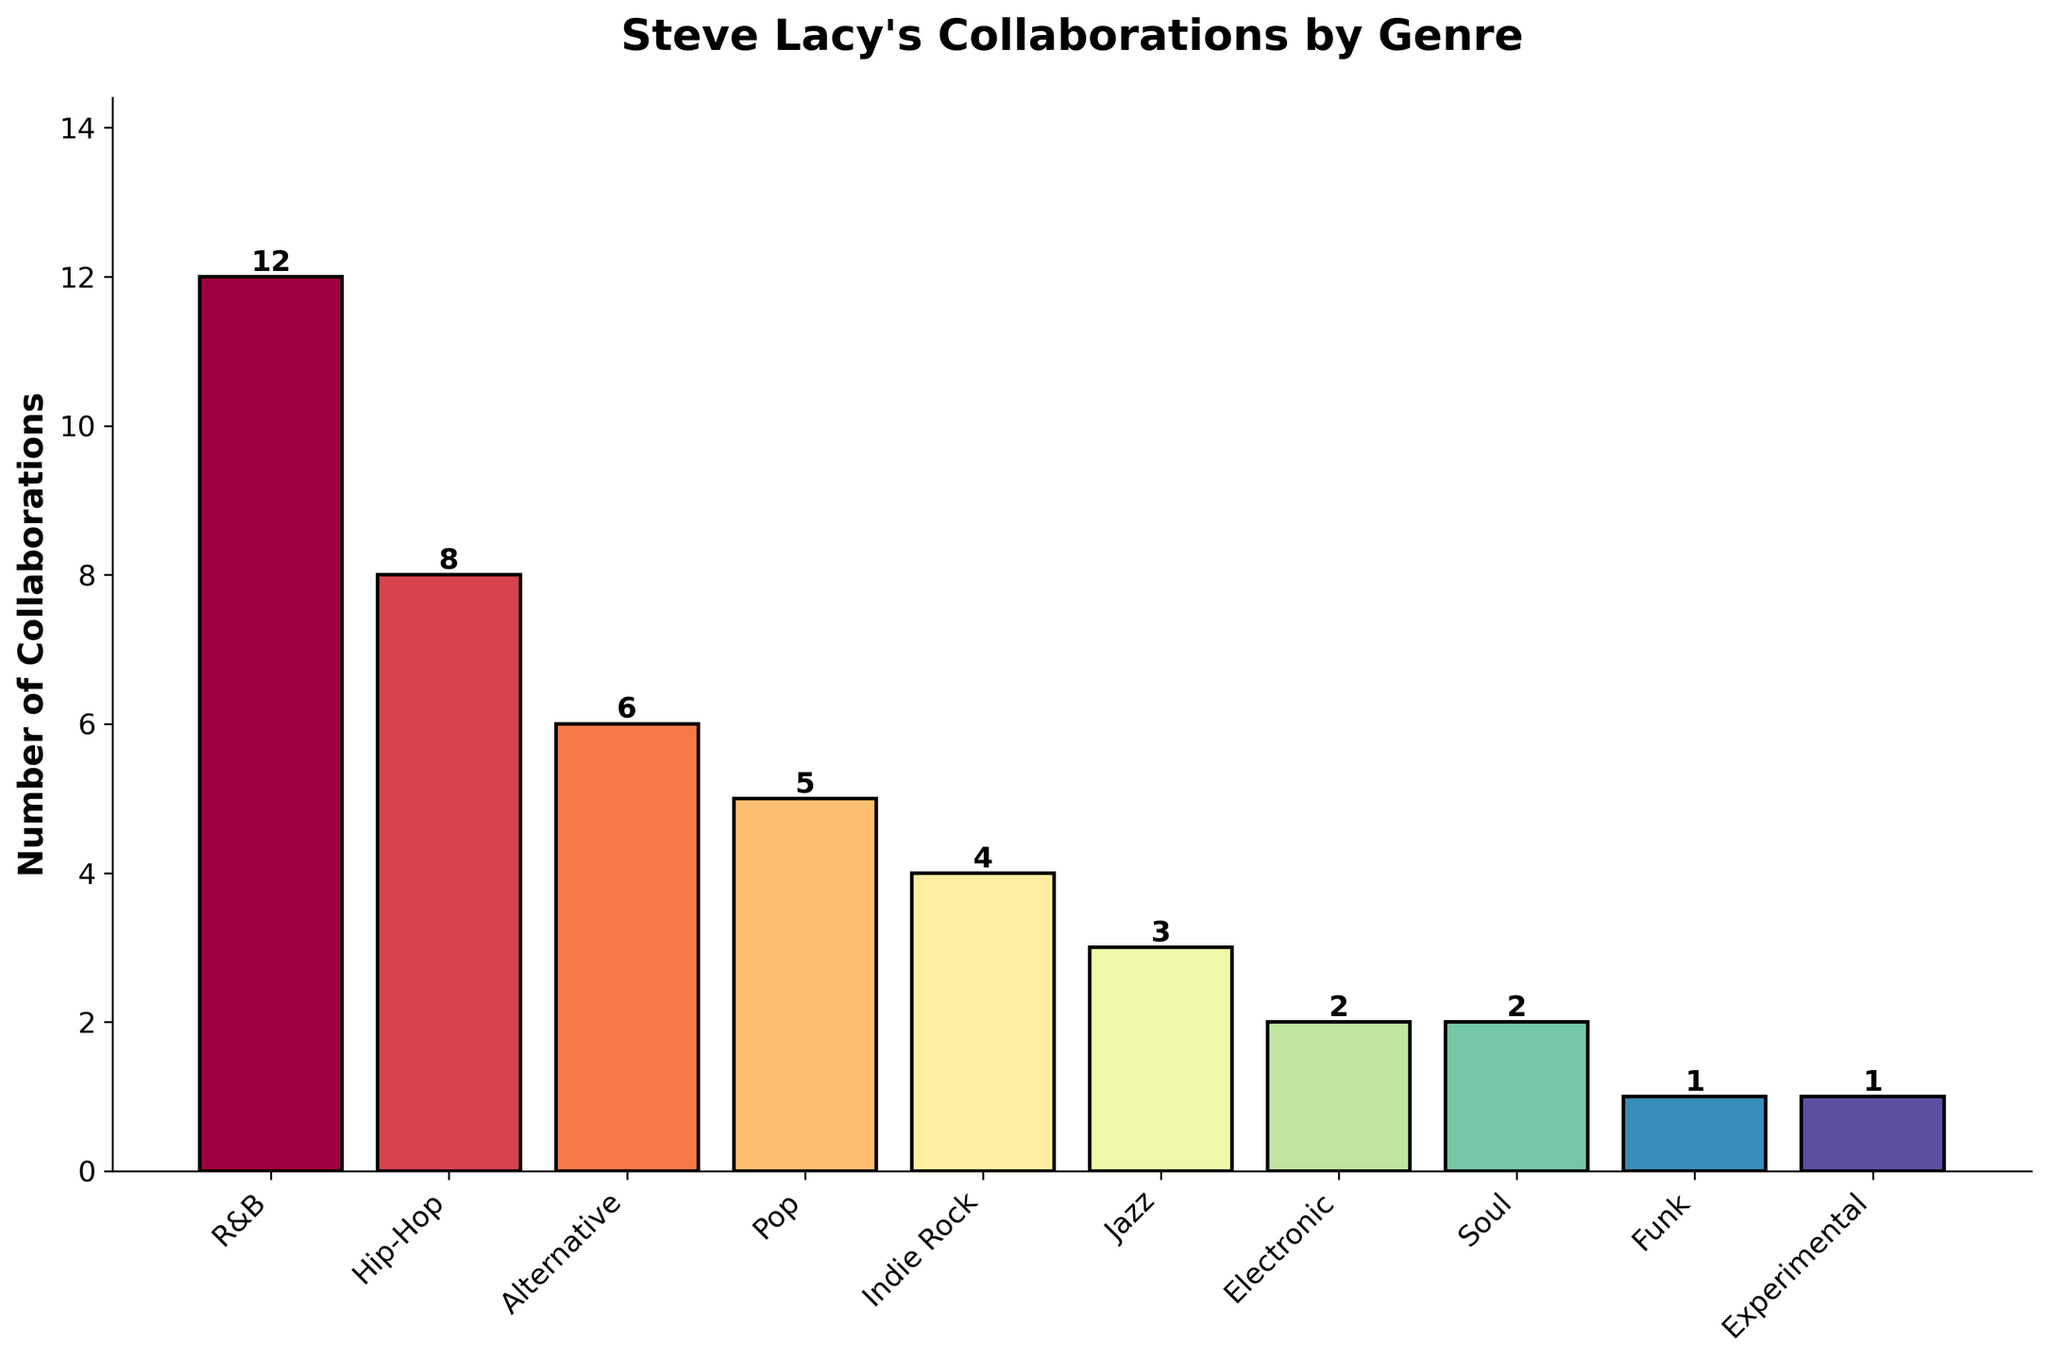what's the total number of collaborations across all genres? To find the total number of collaborations, add the number of collaborations for each genre. That's 12 (R&B) + 8 (Hip-Hop) + 6 (Alternative) + 5 (Pop) + 4 (Indie Rock) + 3 (Jazz) + 2 (Electronic) + 2 (Soul) + 1 (Funk) + 1 (Experimental). The sum is 44.
Answer: 44 which genre has the most collaborations with Steve Lacy? By comparing the heights of the bars in the chart, we can see that the R&B genre has the tallest bar, indicating the most collaborations.
Answer: R&B how many more collaborations are there in R&B compared to Pop? To find the difference, subtract the number of collaborations in Pop from R&B. So, 12 (R&B) - 5 (Pop) = 7.
Answer: 7 are there any genres with an equal number of collaborations? which are they? By examining the bar heights, we see that both Electronic and Soul have bars of equal height, each indicating 2 collaborations.
Answer: Electronic and Soul what is the average number of collaborations per genre? First, find the total number of collaborations, which is 44. Then, divide this by the total number of genres, which is 10. So, 44 / 10 = 4.4.
Answer: 4.4 which genre has the fewest collaborations with Steve Lacy? By looking at the shortest bars, we see that both Funk and Experimental have only 1 collaboration each, representing the fewest.
Answer: Funk and Experimental what's the difference in collaborations between the genre with the highest collaborations and the genre with the lowest collaborations? The genre with the highest is R&B (12 collaborations) and the genre with the lowest is both Funk and Experimental (1 collaboration each). The difference is 12 - 1 = 11.
Answer: 11 how does the number of collaborations in Hip-Hop compare to Alternative? The Hip-Hop genre has 8 collaborations and Alternative has 6. Since 8 is greater than 6, Hip-Hop has more collaborations.
Answer: Hip-Hop has more which genres have fewer than 5 collaborations with Steve Lacy? By identifying the bars that are shorter than the one representing 5 collaborations, the genres are Indie Rock (4), Jazz (3), Electronic (2), Soul (2), Funk (1), and Experimental (1).
Answer: Indie Rock, Jazz, Electronic, Soul, Funk, Experimental what is the combined number of collaborations for Alternative and Indie Rock? Add the number of collaborations for Alternative and Indie Rock. So, 6 (Alternative) + 4 (Indie Rock) = 10.
Answer: 10 